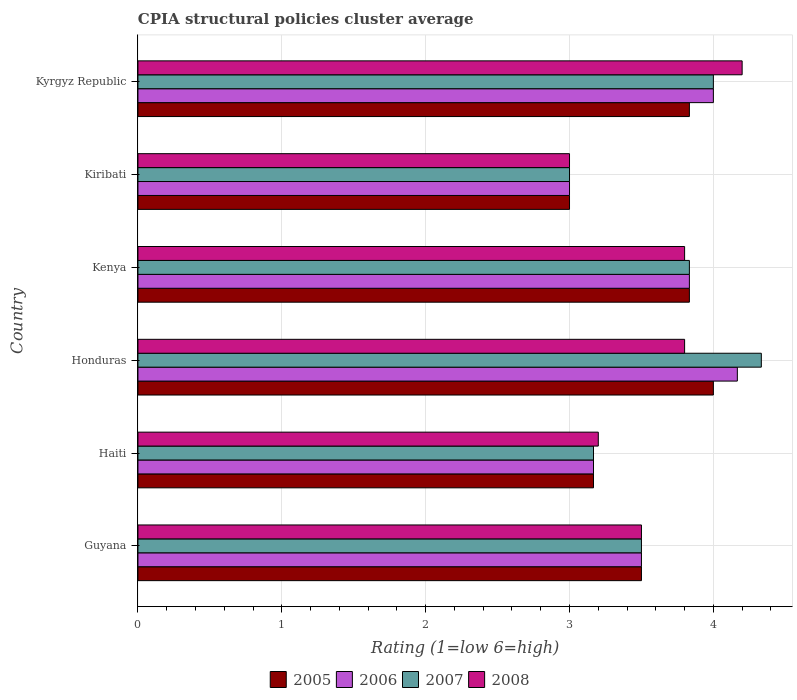How many different coloured bars are there?
Make the answer very short. 4. How many groups of bars are there?
Make the answer very short. 6. Are the number of bars on each tick of the Y-axis equal?
Ensure brevity in your answer.  Yes. How many bars are there on the 4th tick from the bottom?
Your answer should be compact. 4. What is the label of the 4th group of bars from the top?
Your response must be concise. Honduras. Across all countries, what is the maximum CPIA rating in 2005?
Your answer should be compact. 4. In which country was the CPIA rating in 2008 maximum?
Provide a succinct answer. Kyrgyz Republic. In which country was the CPIA rating in 2007 minimum?
Provide a succinct answer. Kiribati. What is the total CPIA rating in 2005 in the graph?
Your answer should be compact. 21.33. What is the difference between the CPIA rating in 2005 in Haiti and that in Honduras?
Offer a very short reply. -0.83. What is the difference between the CPIA rating in 2006 in Haiti and the CPIA rating in 2007 in Honduras?
Ensure brevity in your answer.  -1.17. What is the average CPIA rating in 2005 per country?
Ensure brevity in your answer.  3.56. What is the difference between the CPIA rating in 2006 and CPIA rating in 2005 in Kenya?
Ensure brevity in your answer.  0. In how many countries, is the CPIA rating in 2006 greater than 3.6 ?
Make the answer very short. 3. What is the ratio of the CPIA rating in 2008 in Haiti to that in Kenya?
Ensure brevity in your answer.  0.84. Is the CPIA rating in 2006 in Honduras less than that in Kenya?
Your response must be concise. No. What is the difference between the highest and the second highest CPIA rating in 2006?
Give a very brief answer. 0.17. What is the difference between the highest and the lowest CPIA rating in 2007?
Your answer should be compact. 1.33. Is the sum of the CPIA rating in 2005 in Kenya and Kyrgyz Republic greater than the maximum CPIA rating in 2007 across all countries?
Keep it short and to the point. Yes. Is it the case that in every country, the sum of the CPIA rating in 2006 and CPIA rating in 2005 is greater than the sum of CPIA rating in 2007 and CPIA rating in 2008?
Provide a succinct answer. No. What does the 1st bar from the top in Haiti represents?
Keep it short and to the point. 2008. What does the 3rd bar from the bottom in Kyrgyz Republic represents?
Provide a succinct answer. 2007. Is it the case that in every country, the sum of the CPIA rating in 2005 and CPIA rating in 2008 is greater than the CPIA rating in 2006?
Your response must be concise. Yes. How many countries are there in the graph?
Your response must be concise. 6. What is the difference between two consecutive major ticks on the X-axis?
Provide a succinct answer. 1. Are the values on the major ticks of X-axis written in scientific E-notation?
Keep it short and to the point. No. Does the graph contain any zero values?
Provide a short and direct response. No. Does the graph contain grids?
Offer a very short reply. Yes. How are the legend labels stacked?
Provide a succinct answer. Horizontal. What is the title of the graph?
Ensure brevity in your answer.  CPIA structural policies cluster average. Does "1969" appear as one of the legend labels in the graph?
Make the answer very short. No. What is the label or title of the X-axis?
Make the answer very short. Rating (1=low 6=high). What is the label or title of the Y-axis?
Make the answer very short. Country. What is the Rating (1=low 6=high) in 2006 in Guyana?
Ensure brevity in your answer.  3.5. What is the Rating (1=low 6=high) in 2007 in Guyana?
Provide a succinct answer. 3.5. What is the Rating (1=low 6=high) in 2005 in Haiti?
Your answer should be very brief. 3.17. What is the Rating (1=low 6=high) in 2006 in Haiti?
Your answer should be very brief. 3.17. What is the Rating (1=low 6=high) in 2007 in Haiti?
Give a very brief answer. 3.17. What is the Rating (1=low 6=high) of 2006 in Honduras?
Your answer should be very brief. 4.17. What is the Rating (1=low 6=high) of 2007 in Honduras?
Provide a succinct answer. 4.33. What is the Rating (1=low 6=high) in 2008 in Honduras?
Offer a terse response. 3.8. What is the Rating (1=low 6=high) in 2005 in Kenya?
Keep it short and to the point. 3.83. What is the Rating (1=low 6=high) in 2006 in Kenya?
Keep it short and to the point. 3.83. What is the Rating (1=low 6=high) of 2007 in Kenya?
Offer a terse response. 3.83. What is the Rating (1=low 6=high) in 2008 in Kenya?
Offer a very short reply. 3.8. What is the Rating (1=low 6=high) of 2005 in Kiribati?
Keep it short and to the point. 3. What is the Rating (1=low 6=high) of 2006 in Kiribati?
Give a very brief answer. 3. What is the Rating (1=low 6=high) in 2007 in Kiribati?
Offer a very short reply. 3. What is the Rating (1=low 6=high) in 2008 in Kiribati?
Your answer should be very brief. 3. What is the Rating (1=low 6=high) of 2005 in Kyrgyz Republic?
Your answer should be compact. 3.83. What is the Rating (1=low 6=high) of 2006 in Kyrgyz Republic?
Make the answer very short. 4. What is the Rating (1=low 6=high) in 2008 in Kyrgyz Republic?
Keep it short and to the point. 4.2. Across all countries, what is the maximum Rating (1=low 6=high) in 2006?
Ensure brevity in your answer.  4.17. Across all countries, what is the maximum Rating (1=low 6=high) of 2007?
Provide a succinct answer. 4.33. Across all countries, what is the minimum Rating (1=low 6=high) of 2006?
Provide a succinct answer. 3. What is the total Rating (1=low 6=high) in 2005 in the graph?
Provide a short and direct response. 21.33. What is the total Rating (1=low 6=high) of 2006 in the graph?
Ensure brevity in your answer.  21.67. What is the total Rating (1=low 6=high) in 2007 in the graph?
Your response must be concise. 21.83. What is the difference between the Rating (1=low 6=high) of 2005 in Guyana and that in Haiti?
Give a very brief answer. 0.33. What is the difference between the Rating (1=low 6=high) of 2006 in Guyana and that in Haiti?
Provide a short and direct response. 0.33. What is the difference between the Rating (1=low 6=high) of 2008 in Guyana and that in Haiti?
Ensure brevity in your answer.  0.3. What is the difference between the Rating (1=low 6=high) in 2008 in Guyana and that in Honduras?
Offer a terse response. -0.3. What is the difference between the Rating (1=low 6=high) of 2007 in Guyana and that in Kenya?
Make the answer very short. -0.33. What is the difference between the Rating (1=low 6=high) of 2005 in Guyana and that in Kiribati?
Your response must be concise. 0.5. What is the difference between the Rating (1=low 6=high) in 2006 in Guyana and that in Kiribati?
Ensure brevity in your answer.  0.5. What is the difference between the Rating (1=low 6=high) in 2007 in Guyana and that in Kiribati?
Offer a very short reply. 0.5. What is the difference between the Rating (1=low 6=high) of 2008 in Guyana and that in Kiribati?
Your answer should be very brief. 0.5. What is the difference between the Rating (1=low 6=high) of 2005 in Guyana and that in Kyrgyz Republic?
Your answer should be compact. -0.33. What is the difference between the Rating (1=low 6=high) of 2006 in Guyana and that in Kyrgyz Republic?
Offer a terse response. -0.5. What is the difference between the Rating (1=low 6=high) in 2007 in Guyana and that in Kyrgyz Republic?
Offer a very short reply. -0.5. What is the difference between the Rating (1=low 6=high) of 2006 in Haiti and that in Honduras?
Your answer should be compact. -1. What is the difference between the Rating (1=low 6=high) in 2007 in Haiti and that in Honduras?
Your answer should be very brief. -1.17. What is the difference between the Rating (1=low 6=high) of 2005 in Haiti and that in Kenya?
Your answer should be very brief. -0.67. What is the difference between the Rating (1=low 6=high) in 2007 in Haiti and that in Kiribati?
Provide a succinct answer. 0.17. What is the difference between the Rating (1=low 6=high) in 2005 in Haiti and that in Kyrgyz Republic?
Provide a succinct answer. -0.67. What is the difference between the Rating (1=low 6=high) in 2006 in Haiti and that in Kyrgyz Republic?
Your answer should be compact. -0.83. What is the difference between the Rating (1=low 6=high) of 2007 in Haiti and that in Kyrgyz Republic?
Your answer should be very brief. -0.83. What is the difference between the Rating (1=low 6=high) in 2005 in Honduras and that in Kenya?
Your answer should be compact. 0.17. What is the difference between the Rating (1=low 6=high) in 2006 in Honduras and that in Kenya?
Provide a short and direct response. 0.33. What is the difference between the Rating (1=low 6=high) in 2008 in Honduras and that in Kenya?
Make the answer very short. 0. What is the difference between the Rating (1=low 6=high) of 2006 in Honduras and that in Kiribati?
Offer a terse response. 1.17. What is the difference between the Rating (1=low 6=high) of 2007 in Honduras and that in Kiribati?
Offer a terse response. 1.33. What is the difference between the Rating (1=low 6=high) in 2008 in Honduras and that in Kiribati?
Your answer should be very brief. 0.8. What is the difference between the Rating (1=low 6=high) of 2005 in Honduras and that in Kyrgyz Republic?
Keep it short and to the point. 0.17. What is the difference between the Rating (1=low 6=high) in 2007 in Kenya and that in Kiribati?
Make the answer very short. 0.83. What is the difference between the Rating (1=low 6=high) of 2005 in Kenya and that in Kyrgyz Republic?
Your response must be concise. 0. What is the difference between the Rating (1=low 6=high) of 2008 in Kenya and that in Kyrgyz Republic?
Offer a very short reply. -0.4. What is the difference between the Rating (1=low 6=high) in 2005 in Kiribati and that in Kyrgyz Republic?
Keep it short and to the point. -0.83. What is the difference between the Rating (1=low 6=high) of 2006 in Kiribati and that in Kyrgyz Republic?
Your answer should be very brief. -1. What is the difference between the Rating (1=low 6=high) in 2007 in Kiribati and that in Kyrgyz Republic?
Offer a very short reply. -1. What is the difference between the Rating (1=low 6=high) in 2008 in Kiribati and that in Kyrgyz Republic?
Provide a succinct answer. -1.2. What is the difference between the Rating (1=low 6=high) of 2005 in Guyana and the Rating (1=low 6=high) of 2007 in Haiti?
Ensure brevity in your answer.  0.33. What is the difference between the Rating (1=low 6=high) in 2005 in Guyana and the Rating (1=low 6=high) in 2008 in Haiti?
Keep it short and to the point. 0.3. What is the difference between the Rating (1=low 6=high) of 2006 in Guyana and the Rating (1=low 6=high) of 2008 in Haiti?
Your answer should be very brief. 0.3. What is the difference between the Rating (1=low 6=high) of 2005 in Guyana and the Rating (1=low 6=high) of 2008 in Honduras?
Give a very brief answer. -0.3. What is the difference between the Rating (1=low 6=high) of 2006 in Guyana and the Rating (1=low 6=high) of 2007 in Honduras?
Offer a terse response. -0.83. What is the difference between the Rating (1=low 6=high) of 2007 in Guyana and the Rating (1=low 6=high) of 2008 in Honduras?
Your answer should be compact. -0.3. What is the difference between the Rating (1=low 6=high) of 2005 in Guyana and the Rating (1=low 6=high) of 2006 in Kenya?
Provide a short and direct response. -0.33. What is the difference between the Rating (1=low 6=high) of 2007 in Guyana and the Rating (1=low 6=high) of 2008 in Kenya?
Your answer should be very brief. -0.3. What is the difference between the Rating (1=low 6=high) of 2005 in Guyana and the Rating (1=low 6=high) of 2007 in Kiribati?
Your answer should be very brief. 0.5. What is the difference between the Rating (1=low 6=high) in 2006 in Guyana and the Rating (1=low 6=high) in 2007 in Kiribati?
Provide a succinct answer. 0.5. What is the difference between the Rating (1=low 6=high) of 2007 in Guyana and the Rating (1=low 6=high) of 2008 in Kiribati?
Offer a terse response. 0.5. What is the difference between the Rating (1=low 6=high) of 2005 in Guyana and the Rating (1=low 6=high) of 2006 in Kyrgyz Republic?
Make the answer very short. -0.5. What is the difference between the Rating (1=low 6=high) of 2006 in Guyana and the Rating (1=low 6=high) of 2008 in Kyrgyz Republic?
Give a very brief answer. -0.7. What is the difference between the Rating (1=low 6=high) in 2007 in Guyana and the Rating (1=low 6=high) in 2008 in Kyrgyz Republic?
Offer a terse response. -0.7. What is the difference between the Rating (1=low 6=high) in 2005 in Haiti and the Rating (1=low 6=high) in 2006 in Honduras?
Your answer should be very brief. -1. What is the difference between the Rating (1=low 6=high) of 2005 in Haiti and the Rating (1=low 6=high) of 2007 in Honduras?
Provide a short and direct response. -1.17. What is the difference between the Rating (1=low 6=high) of 2005 in Haiti and the Rating (1=low 6=high) of 2008 in Honduras?
Ensure brevity in your answer.  -0.63. What is the difference between the Rating (1=low 6=high) in 2006 in Haiti and the Rating (1=low 6=high) in 2007 in Honduras?
Give a very brief answer. -1.17. What is the difference between the Rating (1=low 6=high) in 2006 in Haiti and the Rating (1=low 6=high) in 2008 in Honduras?
Your response must be concise. -0.63. What is the difference between the Rating (1=low 6=high) of 2007 in Haiti and the Rating (1=low 6=high) of 2008 in Honduras?
Ensure brevity in your answer.  -0.63. What is the difference between the Rating (1=low 6=high) in 2005 in Haiti and the Rating (1=low 6=high) in 2006 in Kenya?
Make the answer very short. -0.67. What is the difference between the Rating (1=low 6=high) of 2005 in Haiti and the Rating (1=low 6=high) of 2007 in Kenya?
Your answer should be very brief. -0.67. What is the difference between the Rating (1=low 6=high) in 2005 in Haiti and the Rating (1=low 6=high) in 2008 in Kenya?
Provide a short and direct response. -0.63. What is the difference between the Rating (1=low 6=high) in 2006 in Haiti and the Rating (1=low 6=high) in 2007 in Kenya?
Make the answer very short. -0.67. What is the difference between the Rating (1=low 6=high) of 2006 in Haiti and the Rating (1=low 6=high) of 2008 in Kenya?
Give a very brief answer. -0.63. What is the difference between the Rating (1=low 6=high) of 2007 in Haiti and the Rating (1=low 6=high) of 2008 in Kenya?
Your response must be concise. -0.63. What is the difference between the Rating (1=low 6=high) in 2005 in Haiti and the Rating (1=low 6=high) in 2007 in Kiribati?
Offer a terse response. 0.17. What is the difference between the Rating (1=low 6=high) of 2006 in Haiti and the Rating (1=low 6=high) of 2008 in Kiribati?
Ensure brevity in your answer.  0.17. What is the difference between the Rating (1=low 6=high) of 2005 in Haiti and the Rating (1=low 6=high) of 2008 in Kyrgyz Republic?
Offer a terse response. -1.03. What is the difference between the Rating (1=low 6=high) in 2006 in Haiti and the Rating (1=low 6=high) in 2007 in Kyrgyz Republic?
Give a very brief answer. -0.83. What is the difference between the Rating (1=low 6=high) in 2006 in Haiti and the Rating (1=low 6=high) in 2008 in Kyrgyz Republic?
Give a very brief answer. -1.03. What is the difference between the Rating (1=low 6=high) of 2007 in Haiti and the Rating (1=low 6=high) of 2008 in Kyrgyz Republic?
Offer a terse response. -1.03. What is the difference between the Rating (1=low 6=high) of 2005 in Honduras and the Rating (1=low 6=high) of 2006 in Kenya?
Provide a succinct answer. 0.17. What is the difference between the Rating (1=low 6=high) of 2005 in Honduras and the Rating (1=low 6=high) of 2007 in Kenya?
Make the answer very short. 0.17. What is the difference between the Rating (1=low 6=high) in 2005 in Honduras and the Rating (1=low 6=high) in 2008 in Kenya?
Make the answer very short. 0.2. What is the difference between the Rating (1=low 6=high) of 2006 in Honduras and the Rating (1=low 6=high) of 2008 in Kenya?
Provide a short and direct response. 0.37. What is the difference between the Rating (1=low 6=high) of 2007 in Honduras and the Rating (1=low 6=high) of 2008 in Kenya?
Provide a short and direct response. 0.53. What is the difference between the Rating (1=low 6=high) of 2006 in Honduras and the Rating (1=low 6=high) of 2008 in Kiribati?
Ensure brevity in your answer.  1.17. What is the difference between the Rating (1=low 6=high) in 2005 in Honduras and the Rating (1=low 6=high) in 2006 in Kyrgyz Republic?
Offer a very short reply. 0. What is the difference between the Rating (1=low 6=high) of 2006 in Honduras and the Rating (1=low 6=high) of 2007 in Kyrgyz Republic?
Your answer should be compact. 0.17. What is the difference between the Rating (1=low 6=high) in 2006 in Honduras and the Rating (1=low 6=high) in 2008 in Kyrgyz Republic?
Provide a succinct answer. -0.03. What is the difference between the Rating (1=low 6=high) of 2007 in Honduras and the Rating (1=low 6=high) of 2008 in Kyrgyz Republic?
Make the answer very short. 0.13. What is the difference between the Rating (1=low 6=high) of 2005 in Kenya and the Rating (1=low 6=high) of 2008 in Kyrgyz Republic?
Provide a short and direct response. -0.37. What is the difference between the Rating (1=low 6=high) in 2006 in Kenya and the Rating (1=low 6=high) in 2007 in Kyrgyz Republic?
Your answer should be very brief. -0.17. What is the difference between the Rating (1=low 6=high) of 2006 in Kenya and the Rating (1=low 6=high) of 2008 in Kyrgyz Republic?
Offer a very short reply. -0.37. What is the difference between the Rating (1=low 6=high) in 2007 in Kenya and the Rating (1=low 6=high) in 2008 in Kyrgyz Republic?
Your response must be concise. -0.37. What is the difference between the Rating (1=low 6=high) of 2007 in Kiribati and the Rating (1=low 6=high) of 2008 in Kyrgyz Republic?
Ensure brevity in your answer.  -1.2. What is the average Rating (1=low 6=high) in 2005 per country?
Provide a short and direct response. 3.56. What is the average Rating (1=low 6=high) of 2006 per country?
Give a very brief answer. 3.61. What is the average Rating (1=low 6=high) in 2007 per country?
Your response must be concise. 3.64. What is the average Rating (1=low 6=high) of 2008 per country?
Give a very brief answer. 3.58. What is the difference between the Rating (1=low 6=high) of 2006 and Rating (1=low 6=high) of 2007 in Guyana?
Keep it short and to the point. 0. What is the difference between the Rating (1=low 6=high) of 2007 and Rating (1=low 6=high) of 2008 in Guyana?
Give a very brief answer. 0. What is the difference between the Rating (1=low 6=high) in 2005 and Rating (1=low 6=high) in 2006 in Haiti?
Offer a terse response. 0. What is the difference between the Rating (1=low 6=high) of 2005 and Rating (1=low 6=high) of 2008 in Haiti?
Keep it short and to the point. -0.03. What is the difference between the Rating (1=low 6=high) of 2006 and Rating (1=low 6=high) of 2007 in Haiti?
Provide a short and direct response. 0. What is the difference between the Rating (1=low 6=high) of 2006 and Rating (1=low 6=high) of 2008 in Haiti?
Keep it short and to the point. -0.03. What is the difference between the Rating (1=low 6=high) in 2007 and Rating (1=low 6=high) in 2008 in Haiti?
Keep it short and to the point. -0.03. What is the difference between the Rating (1=low 6=high) of 2005 and Rating (1=low 6=high) of 2006 in Honduras?
Give a very brief answer. -0.17. What is the difference between the Rating (1=low 6=high) of 2005 and Rating (1=low 6=high) of 2007 in Honduras?
Your response must be concise. -0.33. What is the difference between the Rating (1=low 6=high) in 2005 and Rating (1=low 6=high) in 2008 in Honduras?
Your answer should be compact. 0.2. What is the difference between the Rating (1=low 6=high) of 2006 and Rating (1=low 6=high) of 2007 in Honduras?
Your answer should be compact. -0.17. What is the difference between the Rating (1=low 6=high) of 2006 and Rating (1=low 6=high) of 2008 in Honduras?
Your answer should be compact. 0.37. What is the difference between the Rating (1=low 6=high) of 2007 and Rating (1=low 6=high) of 2008 in Honduras?
Offer a very short reply. 0.53. What is the difference between the Rating (1=low 6=high) in 2006 and Rating (1=low 6=high) in 2007 in Kenya?
Your answer should be compact. 0. What is the difference between the Rating (1=low 6=high) in 2006 and Rating (1=low 6=high) in 2008 in Kenya?
Offer a terse response. 0.03. What is the difference between the Rating (1=low 6=high) in 2005 and Rating (1=low 6=high) in 2006 in Kiribati?
Ensure brevity in your answer.  0. What is the difference between the Rating (1=low 6=high) in 2005 and Rating (1=low 6=high) in 2007 in Kiribati?
Keep it short and to the point. 0. What is the difference between the Rating (1=low 6=high) of 2005 and Rating (1=low 6=high) of 2008 in Kiribati?
Your answer should be very brief. 0. What is the difference between the Rating (1=low 6=high) in 2006 and Rating (1=low 6=high) in 2007 in Kiribati?
Your answer should be compact. 0. What is the difference between the Rating (1=low 6=high) of 2006 and Rating (1=low 6=high) of 2008 in Kiribati?
Offer a very short reply. 0. What is the difference between the Rating (1=low 6=high) in 2005 and Rating (1=low 6=high) in 2006 in Kyrgyz Republic?
Provide a short and direct response. -0.17. What is the difference between the Rating (1=low 6=high) of 2005 and Rating (1=low 6=high) of 2007 in Kyrgyz Republic?
Offer a terse response. -0.17. What is the difference between the Rating (1=low 6=high) of 2005 and Rating (1=low 6=high) of 2008 in Kyrgyz Republic?
Offer a very short reply. -0.37. What is the difference between the Rating (1=low 6=high) in 2006 and Rating (1=low 6=high) in 2008 in Kyrgyz Republic?
Make the answer very short. -0.2. What is the ratio of the Rating (1=low 6=high) in 2005 in Guyana to that in Haiti?
Your answer should be very brief. 1.11. What is the ratio of the Rating (1=low 6=high) in 2006 in Guyana to that in Haiti?
Give a very brief answer. 1.11. What is the ratio of the Rating (1=low 6=high) in 2007 in Guyana to that in Haiti?
Offer a terse response. 1.11. What is the ratio of the Rating (1=low 6=high) of 2008 in Guyana to that in Haiti?
Offer a very short reply. 1.09. What is the ratio of the Rating (1=low 6=high) in 2005 in Guyana to that in Honduras?
Make the answer very short. 0.88. What is the ratio of the Rating (1=low 6=high) of 2006 in Guyana to that in Honduras?
Provide a short and direct response. 0.84. What is the ratio of the Rating (1=low 6=high) in 2007 in Guyana to that in Honduras?
Your answer should be very brief. 0.81. What is the ratio of the Rating (1=low 6=high) of 2008 in Guyana to that in Honduras?
Provide a succinct answer. 0.92. What is the ratio of the Rating (1=low 6=high) in 2005 in Guyana to that in Kenya?
Your answer should be compact. 0.91. What is the ratio of the Rating (1=low 6=high) in 2008 in Guyana to that in Kenya?
Your answer should be very brief. 0.92. What is the ratio of the Rating (1=low 6=high) in 2006 in Guyana to that in Kiribati?
Offer a terse response. 1.17. What is the ratio of the Rating (1=low 6=high) of 2006 in Guyana to that in Kyrgyz Republic?
Offer a terse response. 0.88. What is the ratio of the Rating (1=low 6=high) of 2008 in Guyana to that in Kyrgyz Republic?
Give a very brief answer. 0.83. What is the ratio of the Rating (1=low 6=high) of 2005 in Haiti to that in Honduras?
Ensure brevity in your answer.  0.79. What is the ratio of the Rating (1=low 6=high) in 2006 in Haiti to that in Honduras?
Your answer should be compact. 0.76. What is the ratio of the Rating (1=low 6=high) in 2007 in Haiti to that in Honduras?
Provide a short and direct response. 0.73. What is the ratio of the Rating (1=low 6=high) in 2008 in Haiti to that in Honduras?
Your response must be concise. 0.84. What is the ratio of the Rating (1=low 6=high) in 2005 in Haiti to that in Kenya?
Offer a very short reply. 0.83. What is the ratio of the Rating (1=low 6=high) of 2006 in Haiti to that in Kenya?
Your response must be concise. 0.83. What is the ratio of the Rating (1=low 6=high) of 2007 in Haiti to that in Kenya?
Provide a short and direct response. 0.83. What is the ratio of the Rating (1=low 6=high) in 2008 in Haiti to that in Kenya?
Provide a short and direct response. 0.84. What is the ratio of the Rating (1=low 6=high) of 2005 in Haiti to that in Kiribati?
Offer a very short reply. 1.06. What is the ratio of the Rating (1=low 6=high) of 2006 in Haiti to that in Kiribati?
Provide a succinct answer. 1.06. What is the ratio of the Rating (1=low 6=high) of 2007 in Haiti to that in Kiribati?
Make the answer very short. 1.06. What is the ratio of the Rating (1=low 6=high) in 2008 in Haiti to that in Kiribati?
Your response must be concise. 1.07. What is the ratio of the Rating (1=low 6=high) in 2005 in Haiti to that in Kyrgyz Republic?
Keep it short and to the point. 0.83. What is the ratio of the Rating (1=low 6=high) of 2006 in Haiti to that in Kyrgyz Republic?
Your answer should be very brief. 0.79. What is the ratio of the Rating (1=low 6=high) of 2007 in Haiti to that in Kyrgyz Republic?
Provide a succinct answer. 0.79. What is the ratio of the Rating (1=low 6=high) of 2008 in Haiti to that in Kyrgyz Republic?
Provide a short and direct response. 0.76. What is the ratio of the Rating (1=low 6=high) of 2005 in Honduras to that in Kenya?
Offer a terse response. 1.04. What is the ratio of the Rating (1=low 6=high) of 2006 in Honduras to that in Kenya?
Provide a succinct answer. 1.09. What is the ratio of the Rating (1=low 6=high) of 2007 in Honduras to that in Kenya?
Your response must be concise. 1.13. What is the ratio of the Rating (1=low 6=high) of 2008 in Honduras to that in Kenya?
Keep it short and to the point. 1. What is the ratio of the Rating (1=low 6=high) in 2005 in Honduras to that in Kiribati?
Provide a succinct answer. 1.33. What is the ratio of the Rating (1=low 6=high) in 2006 in Honduras to that in Kiribati?
Provide a short and direct response. 1.39. What is the ratio of the Rating (1=low 6=high) in 2007 in Honduras to that in Kiribati?
Provide a short and direct response. 1.44. What is the ratio of the Rating (1=low 6=high) of 2008 in Honduras to that in Kiribati?
Your answer should be very brief. 1.27. What is the ratio of the Rating (1=low 6=high) of 2005 in Honduras to that in Kyrgyz Republic?
Give a very brief answer. 1.04. What is the ratio of the Rating (1=low 6=high) of 2006 in Honduras to that in Kyrgyz Republic?
Offer a terse response. 1.04. What is the ratio of the Rating (1=low 6=high) of 2008 in Honduras to that in Kyrgyz Republic?
Ensure brevity in your answer.  0.9. What is the ratio of the Rating (1=low 6=high) in 2005 in Kenya to that in Kiribati?
Your response must be concise. 1.28. What is the ratio of the Rating (1=low 6=high) of 2006 in Kenya to that in Kiribati?
Your response must be concise. 1.28. What is the ratio of the Rating (1=low 6=high) of 2007 in Kenya to that in Kiribati?
Your response must be concise. 1.28. What is the ratio of the Rating (1=low 6=high) of 2008 in Kenya to that in Kiribati?
Your answer should be compact. 1.27. What is the ratio of the Rating (1=low 6=high) in 2006 in Kenya to that in Kyrgyz Republic?
Your answer should be compact. 0.96. What is the ratio of the Rating (1=low 6=high) of 2008 in Kenya to that in Kyrgyz Republic?
Give a very brief answer. 0.9. What is the ratio of the Rating (1=low 6=high) of 2005 in Kiribati to that in Kyrgyz Republic?
Your response must be concise. 0.78. What is the ratio of the Rating (1=low 6=high) in 2007 in Kiribati to that in Kyrgyz Republic?
Give a very brief answer. 0.75. What is the ratio of the Rating (1=low 6=high) of 2008 in Kiribati to that in Kyrgyz Republic?
Offer a terse response. 0.71. What is the difference between the highest and the second highest Rating (1=low 6=high) in 2007?
Make the answer very short. 0.33. What is the difference between the highest and the second highest Rating (1=low 6=high) of 2008?
Give a very brief answer. 0.4. What is the difference between the highest and the lowest Rating (1=low 6=high) in 2007?
Offer a very short reply. 1.33. 